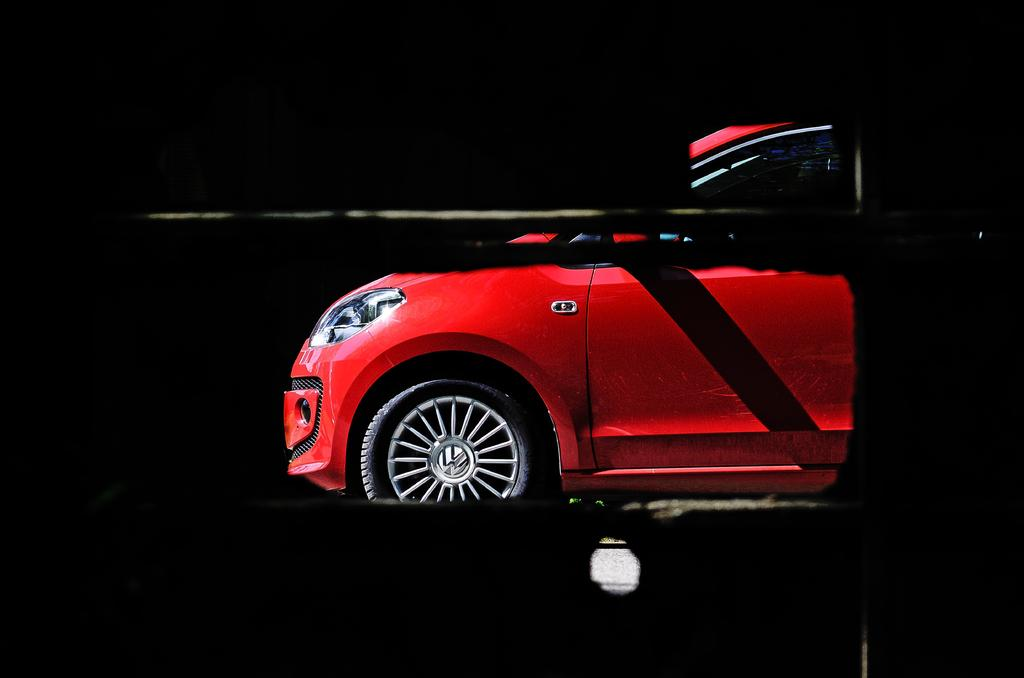What color is the car in the image? The car in the image is red. Can you describe the background of the car? The background of the car is dark. What is the cause of the argument between the two people in the image? There are no people present in the image, and therefore no argument can be observed. 